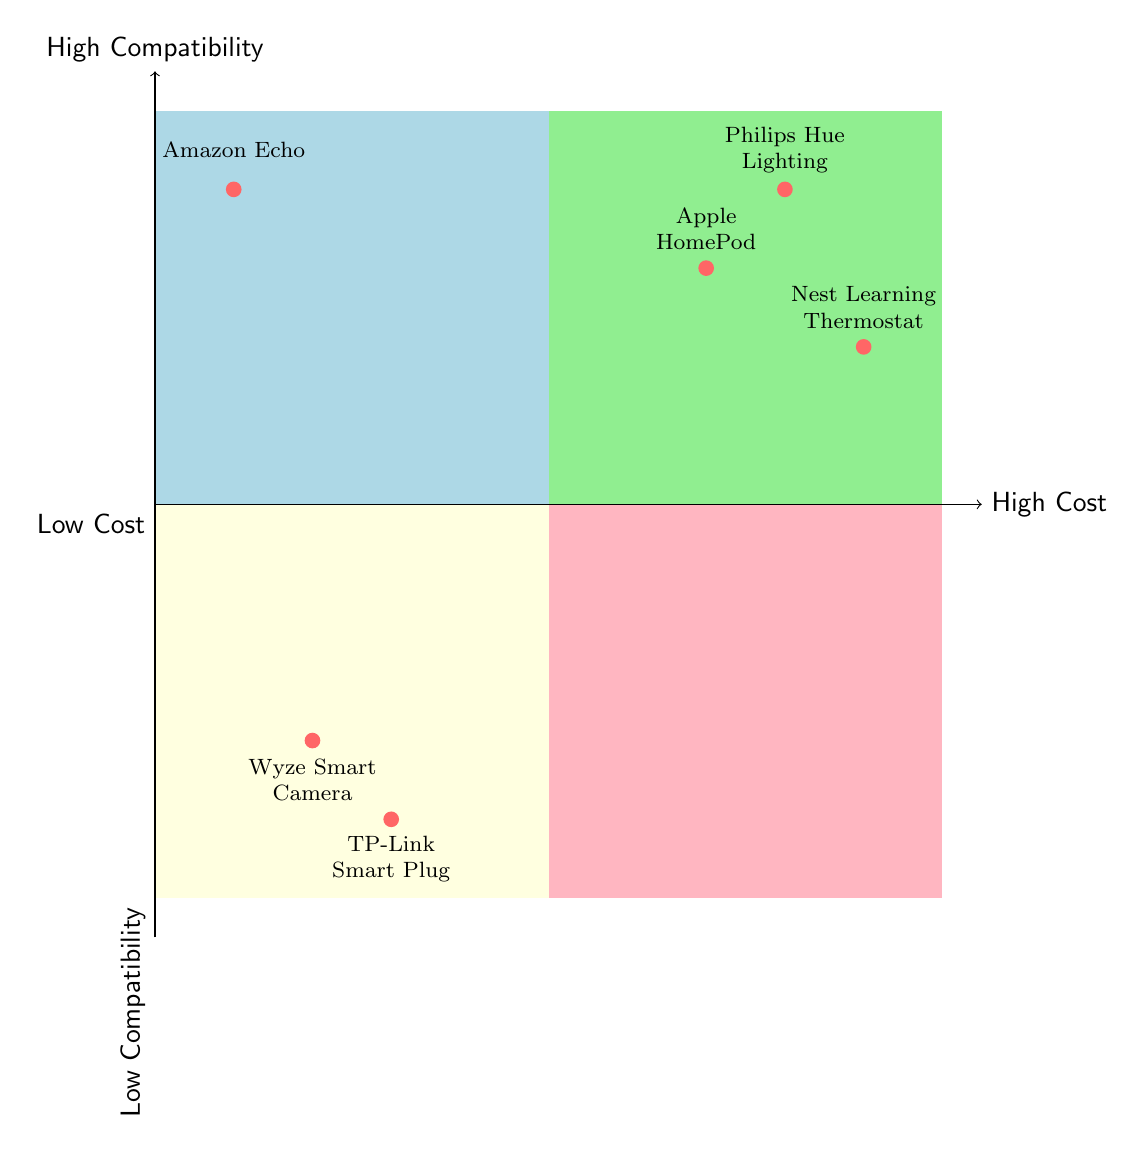What is the most expensive device in the chart? The most expensive device can be found by identifying the nodes labeled as "High Cost." Among these devices, "Philips Hue Lighting," "Apple HomePod," and "Nest Learning Thermostat" are considered. The position of "Philips Hue Lighting" is furthest to the right within the high-cost segment.
Answer: Philips Hue Lighting How many devices have high compatibility? To determine the number of devices with high compatibility, we look at the nodes in the upper half of the quadrant chart. The devices listed here are "Philips Hue Lighting," "Amazon Echo," "Apple HomePod," and "Nest Learning Thermostat," totaling four devices.
Answer: 4 Which device is categorized as low cost and low compatibility? The device in the bottom left quadrant representing low cost and low compatibility is "Wyze Smart Camera" and "TP-Link Smart Plug." Specifically, "Wyze Smart Camera" is found at coordinates indicating both low cost and low compatibility.
Answer: Wyze Smart Camera What is the relationship between the Amazon Echo and Nest Learning Thermostat? The Amazon Echo is placed in the high compatibility, low cost quadrant, while the Nest Learning Thermostat is in the high compatibility, high cost quadrant. They are both categorized as high compatibility devices, but differ in cost classification.
Answer: High compatibility, different costs Which device has high compatibility but low cost? The identification of a device that has high compatibility and is also classified as low cost involves examining devices in the upper left quadrant. The Amazon Echo fulfills these criteria as it is located in that section of the diagram.
Answer: Amazon Echo 